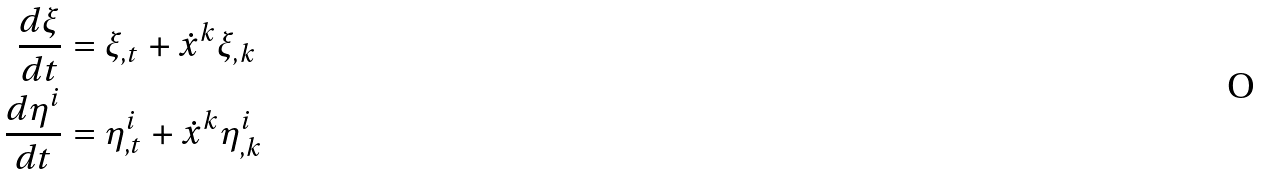Convert formula to latex. <formula><loc_0><loc_0><loc_500><loc_500>\frac { d \xi } { d t } & = \xi _ { , t } + \dot { x } ^ { k } \xi _ { , k } \\ \frac { d \eta ^ { i } } { d t } & = \eta _ { , t } ^ { i } + \dot { x } ^ { k } \eta _ { , k } ^ { i }</formula> 